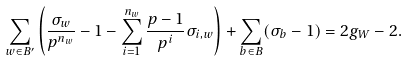Convert formula to latex. <formula><loc_0><loc_0><loc_500><loc_500>\sum _ { w \in B ^ { \prime } } \left ( \frac { \sigma _ { w } } { p ^ { n _ { w } } } - 1 - \sum _ { i = 1 } ^ { n _ { w } } \frac { p - 1 } { p ^ { i } } \sigma _ { i , w } \right ) + \sum _ { b \in B } ( \sigma _ { b } - 1 ) = 2 g _ { W } - 2 .</formula> 